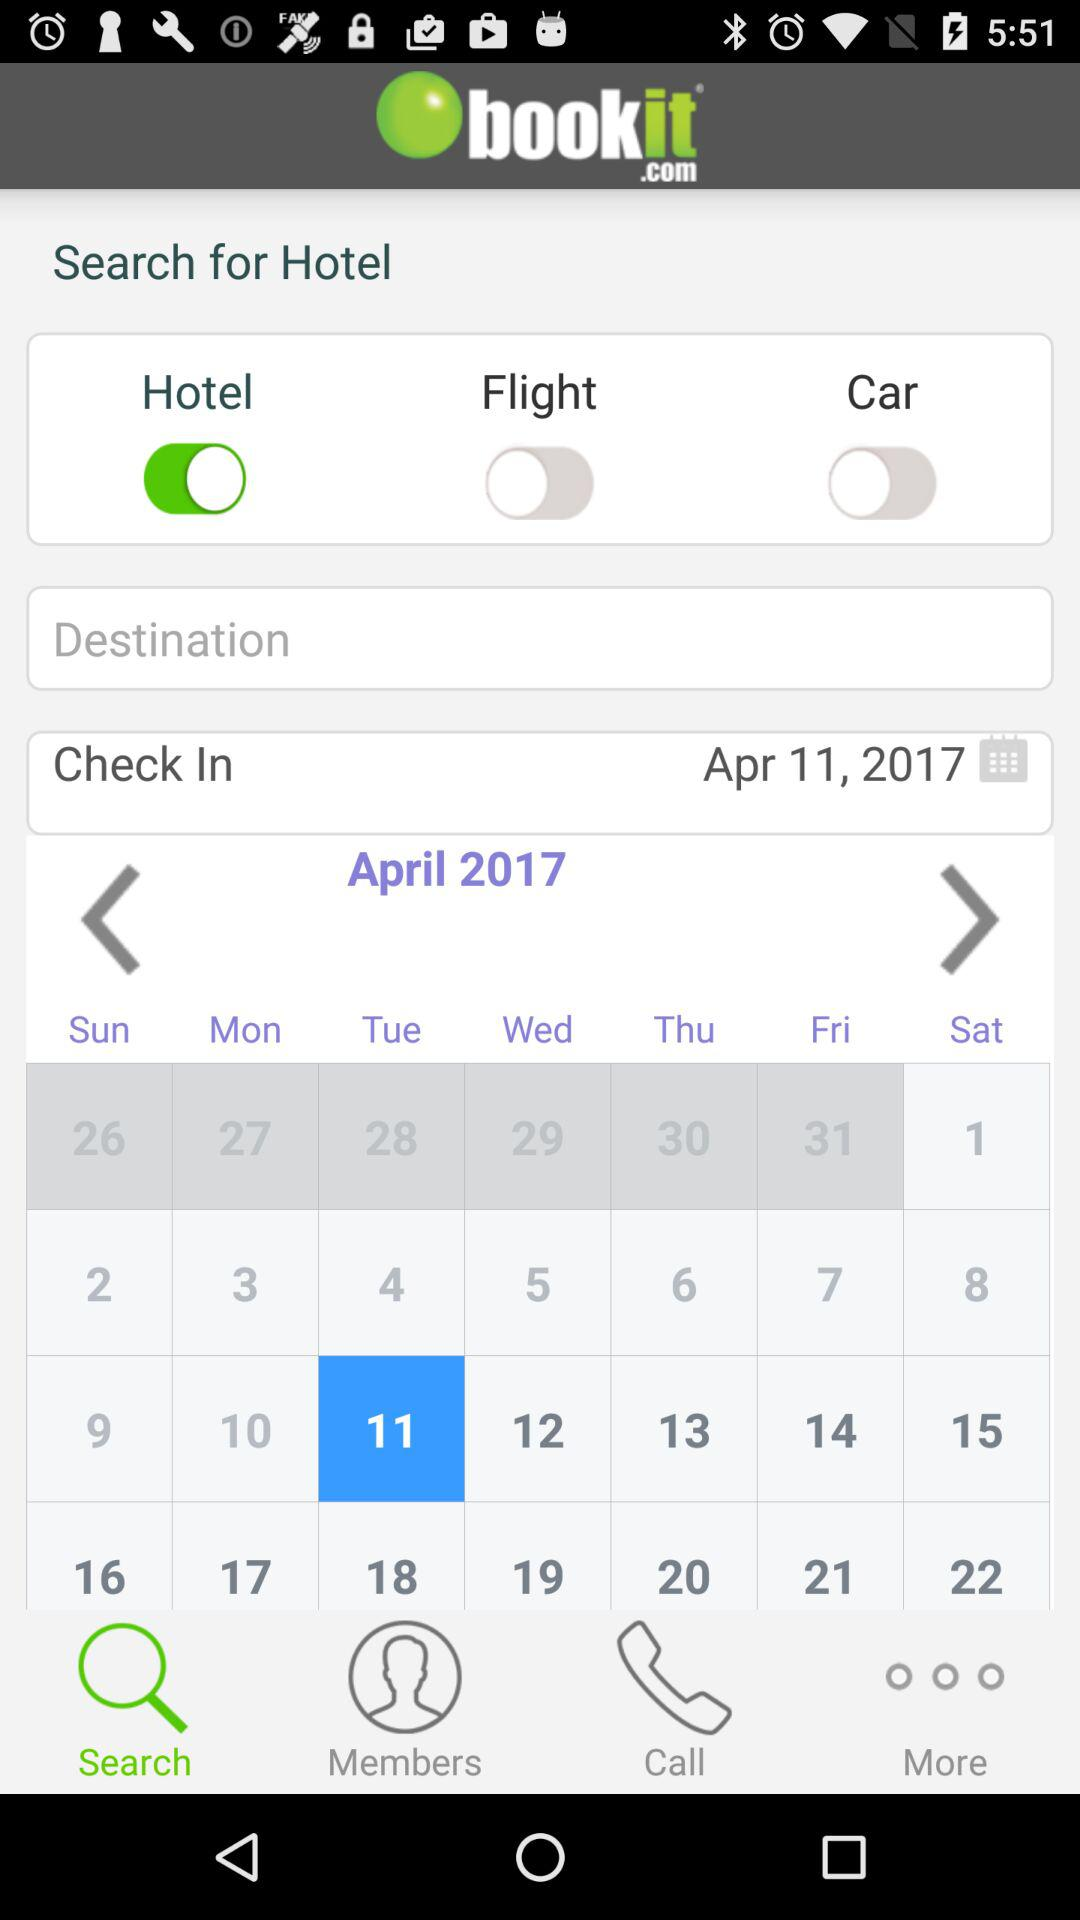What day is 11th of April 2017? The day is Tuesday. 